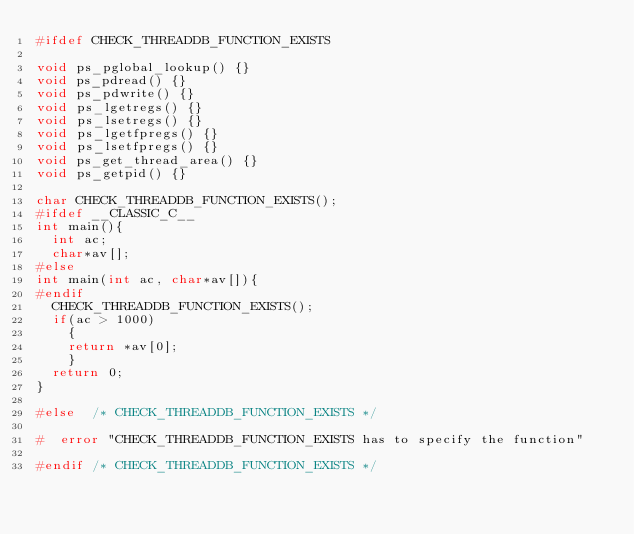<code> <loc_0><loc_0><loc_500><loc_500><_C_>#ifdef CHECK_THREADDB_FUNCTION_EXISTS

void ps_pglobal_lookup() {}
void ps_pdread() {}
void ps_pdwrite() {}
void ps_lgetregs() {}
void ps_lsetregs() {}
void ps_lgetfpregs() {}
void ps_lsetfpregs() {}
void ps_get_thread_area() {}
void ps_getpid() {}

char CHECK_THREADDB_FUNCTION_EXISTS();
#ifdef __CLASSIC_C__
int main(){
  int ac;
  char*av[];
#else
int main(int ac, char*av[]){
#endif
  CHECK_THREADDB_FUNCTION_EXISTS();
  if(ac > 1000)
    {
    return *av[0];
    }
  return 0;
}

#else  /* CHECK_THREADDB_FUNCTION_EXISTS */

#  error "CHECK_THREADDB_FUNCTION_EXISTS has to specify the function"

#endif /* CHECK_THREADDB_FUNCTION_EXISTS */
</code> 